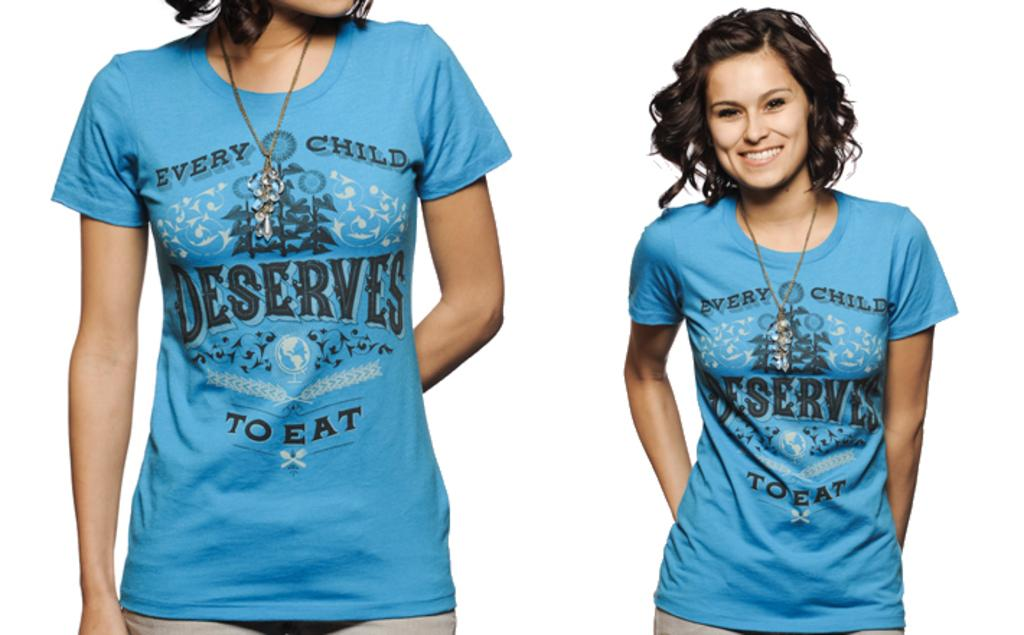<image>
Share a concise interpretation of the image provided. a woman in a shirt that reads: every child deserves to eat 